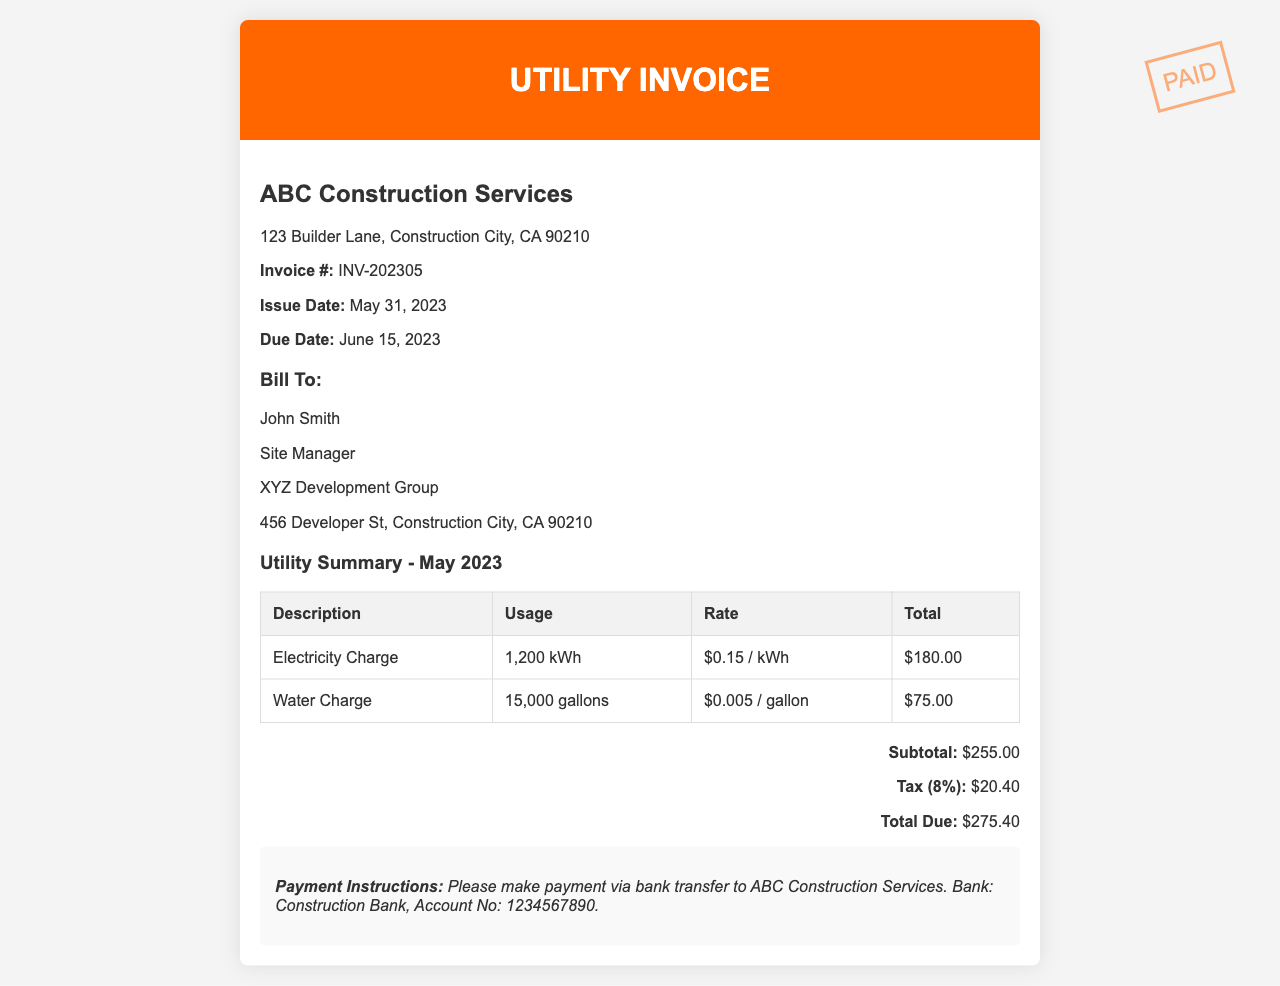what is the invoice number? The invoice number is listed under the company details section as "Invoice #: INV-202305."
Answer: INV-202305 what is the issue date of the invoice? The issue date is found in the company details section, stated as "Issue Date: May 31, 2023."
Answer: May 31, 2023 who is the site manager listed on the invoice? The site manager's name is found in the "Bill To" section, listed as "John Smith."
Answer: John Smith how much is the total due? The total due is calculated at the bottom of the invoice as "Total Due: $275.40."
Answer: $275.40 what is the usage for water charge? The usage for water charge is indicated in the invoice table as "15,000 gallons."
Answer: 15,000 gallons how much is the tax applied to the subtotal? The tax is specified in the totals section as "Tax (8%): $20.40."
Answer: $20.40 what is the rate per kWh for electricity? The rate for electricity is mentioned in the invoice table as "$0.15 / kWh."
Answer: $0.15 / kWh what payment method is instructed for settling the invoice? The payment instructions specify making payment via bank transfer to "ABC Construction Services."
Answer: bank transfer what is the subtotal amount before tax? The subtotal is provided in the totals section as "Subtotal: $255.00."
Answer: $255.00 